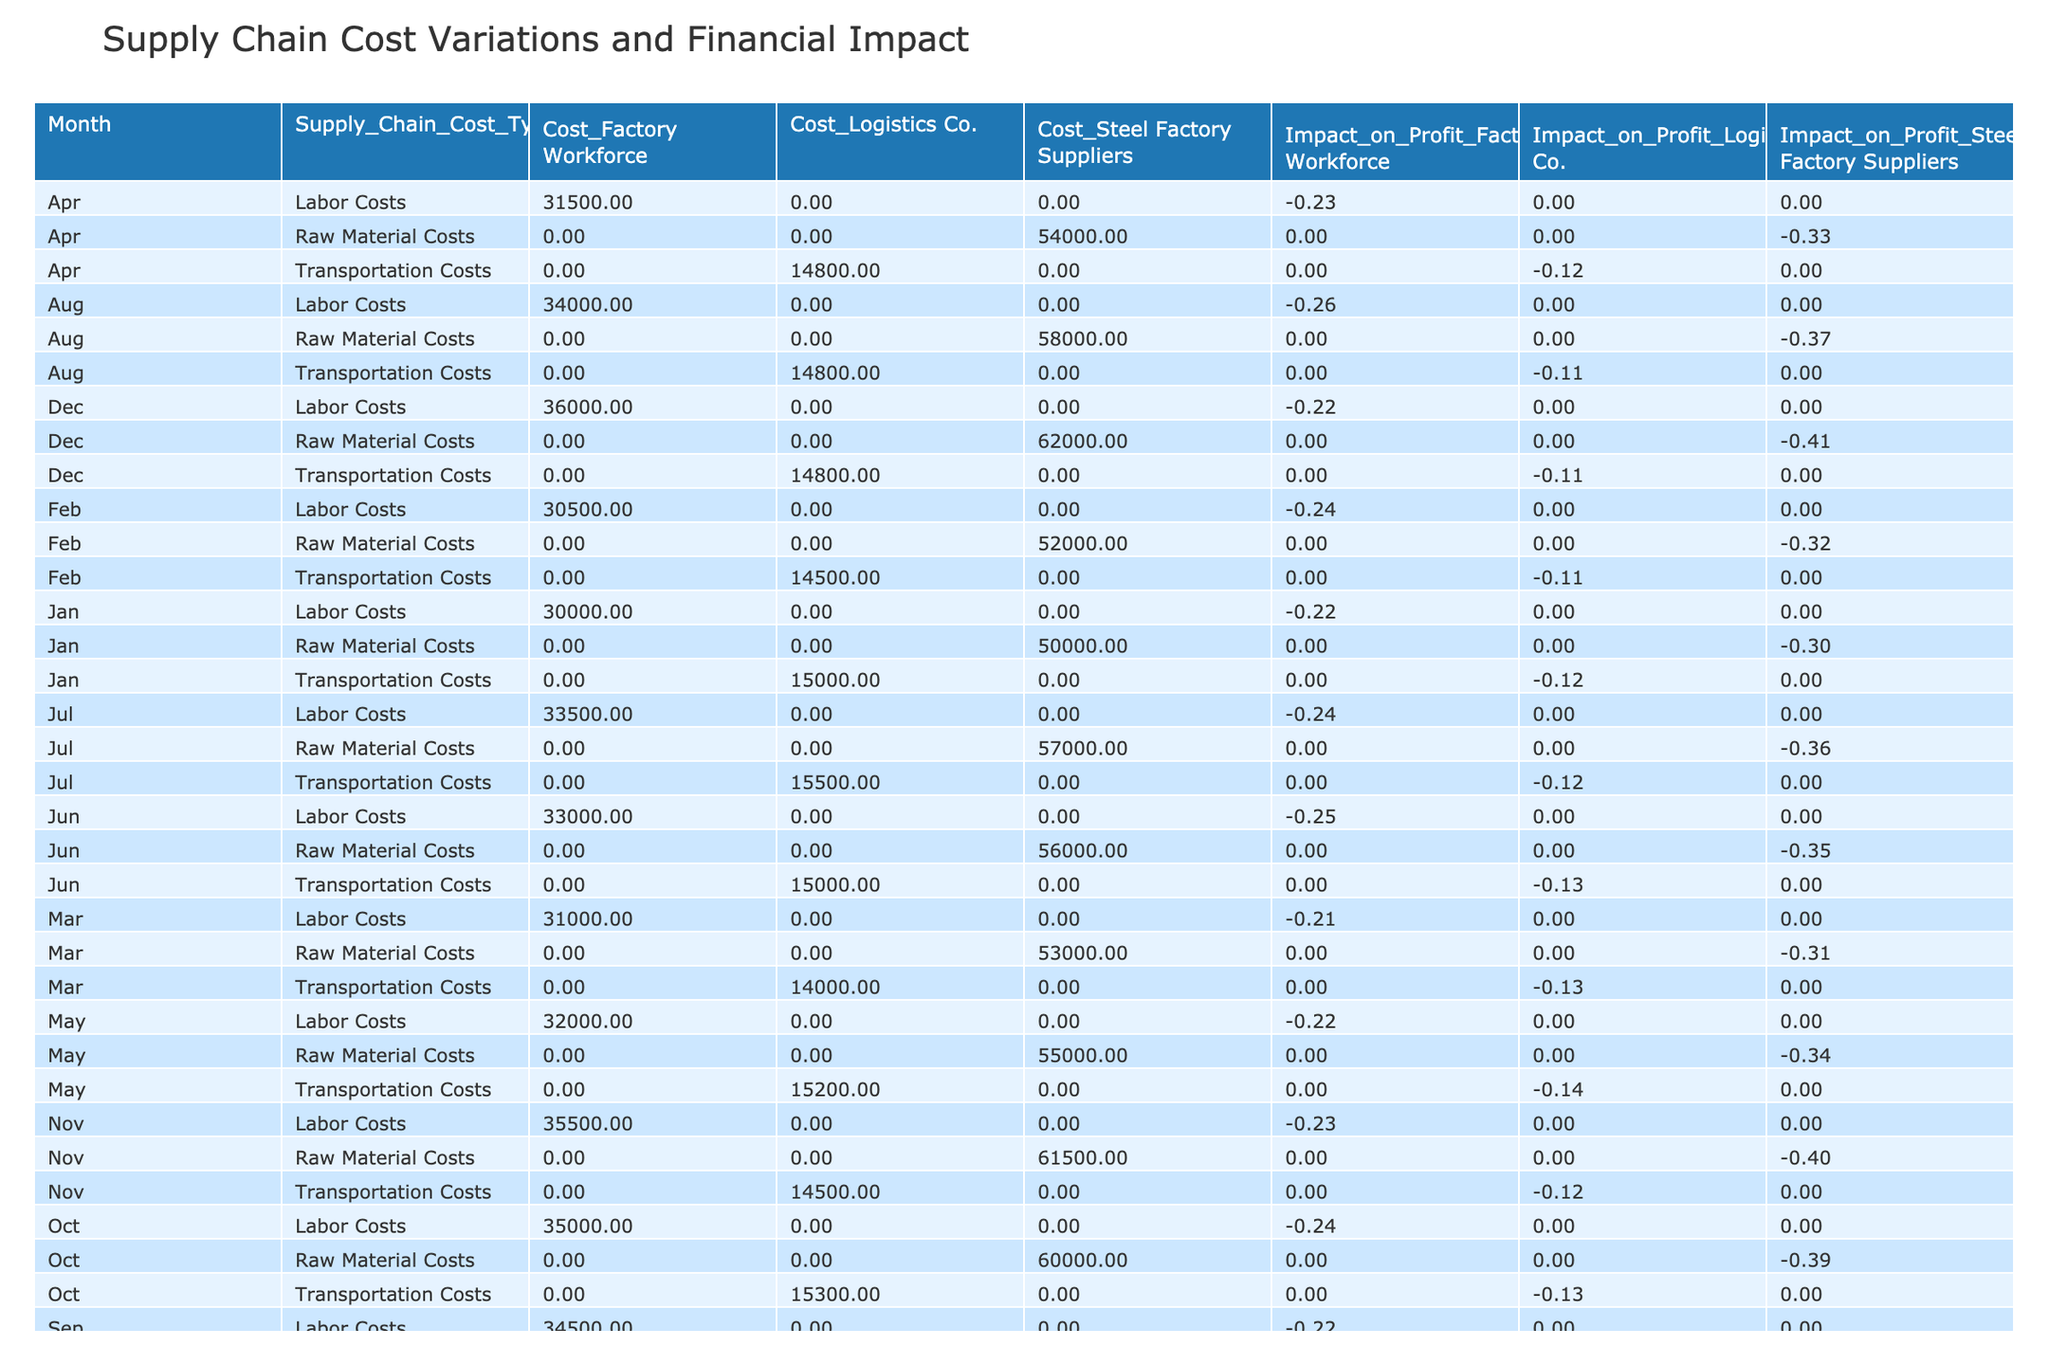What were the raw material costs in December? Referring to the table, the 'Raw Material Costs' under December shows a cost of 62000.
Answer: 62000 What was the total impact on profit from labor costs in January to March? Looking at January, February, and March, the impact on profit from labor costs is -0.22, -0.24, and -0.21 respectively. Summing these values gives -0.22 + -0.24 + -0.21 = -0.67.
Answer: -0.67 Did the transportation costs increase from January to June? By analyzing the transportation costs from January (15000) to June (15000), we can see they remained the same from January to February, decreased from March to June and then increased slightly to 15200 in May. Therefore, it did not consistently increase.
Answer: No What was the average supply chain cost for raw materials in the first quarter? The raw material costs for January, February, and March are 50000, 52000, and 53000. Summing these gives 50000 + 52000 + 53000 = 155000. Dividing by 3 for the average yields 155000 / 3 = 51666.67.
Answer: 51666.67 Which month had the highest transportation cost and what was the cost? Checking the table, the transportation cost peaked in July at 15500.
Answer: 15500 What is the difference in total supply chain costs between raw materials and labor costs in August? In August, raw material costs are 58000 and labor costs are 34000. The difference is 58000 - 34000 = 24000.
Answer: 24000 Did the impact on profit from raw material costs worsen from October to December? In October, the impact was -0.39, and in December, it was -0.41. Since -0.41 is lower than -0.39, the impact on profit did worsen.
Answer: Yes What was the total of raw material costs over the year? Summing the 'Raw Material Costs' for each month results in 50000 (Jan) + 52000 (Feb) + 53000 (Mar) + 54000 (Apr) + 55000 (May) + 56000 (Jun) + 57000 (Jul) + 58000 (Aug) + 59000 (Sep) + 60000 (Oct) + 61500 (Nov) + 62000 (Dec) = 620000.
Answer: 620000 